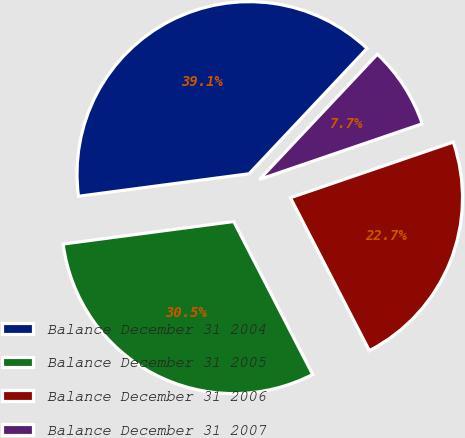Convert chart to OTSL. <chart><loc_0><loc_0><loc_500><loc_500><pie_chart><fcel>Balance December 31 2004<fcel>Balance December 31 2005<fcel>Balance December 31 2006<fcel>Balance December 31 2007<nl><fcel>39.11%<fcel>30.5%<fcel>22.66%<fcel>7.74%<nl></chart> 